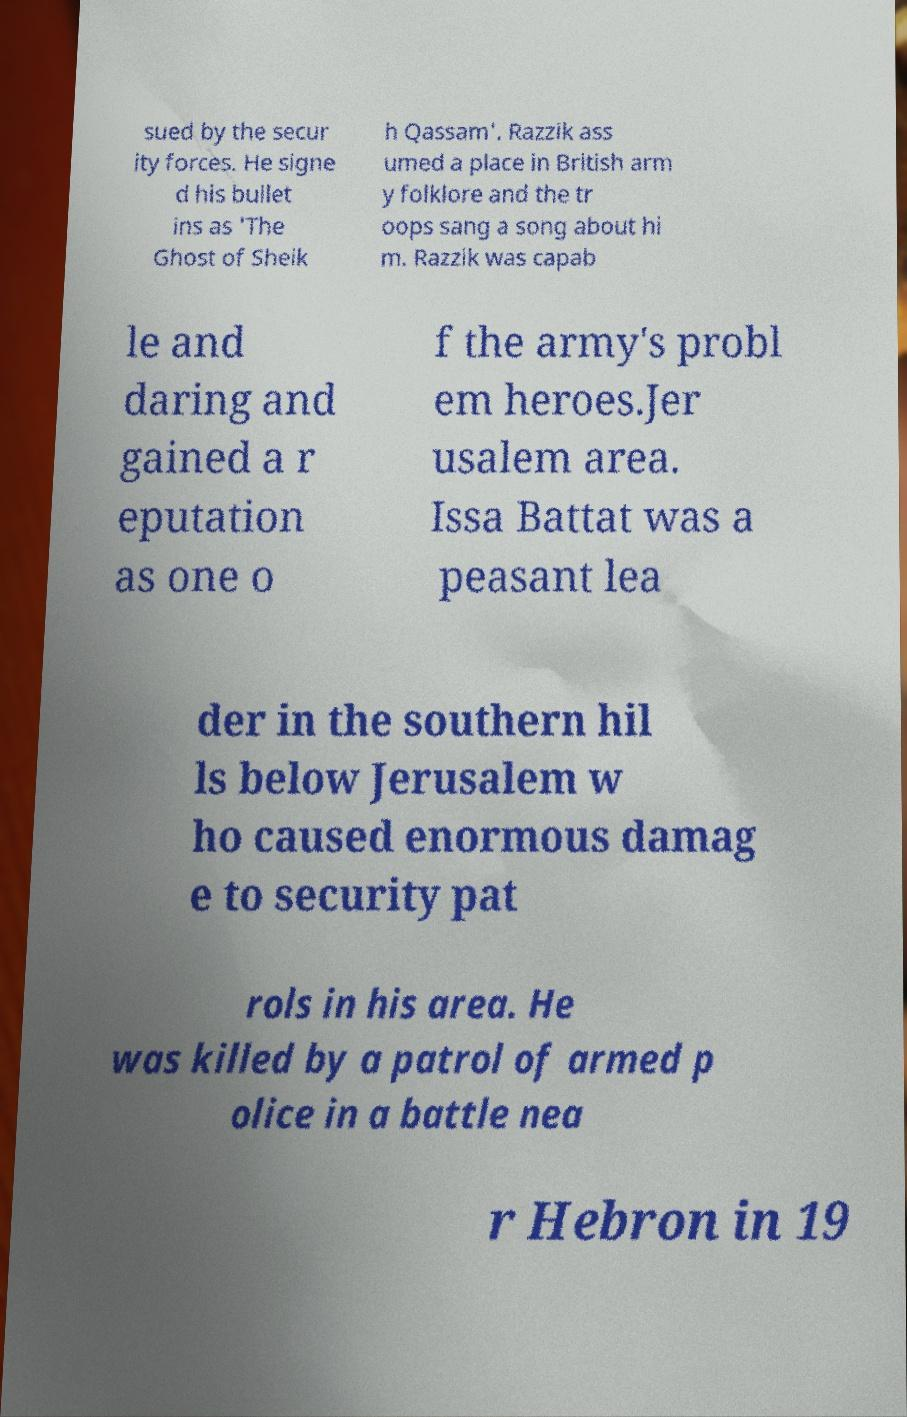Could you extract and type out the text from this image? sued by the secur ity forces. He signe d his bullet ins as 'The Ghost of Sheik h Qassam'. Razzik ass umed a place in British arm y folklore and the tr oops sang a song about hi m. Razzik was capab le and daring and gained a r eputation as one o f the army's probl em heroes.Jer usalem area. Issa Battat was a peasant lea der in the southern hil ls below Jerusalem w ho caused enormous damag e to security pat rols in his area. He was killed by a patrol of armed p olice in a battle nea r Hebron in 19 